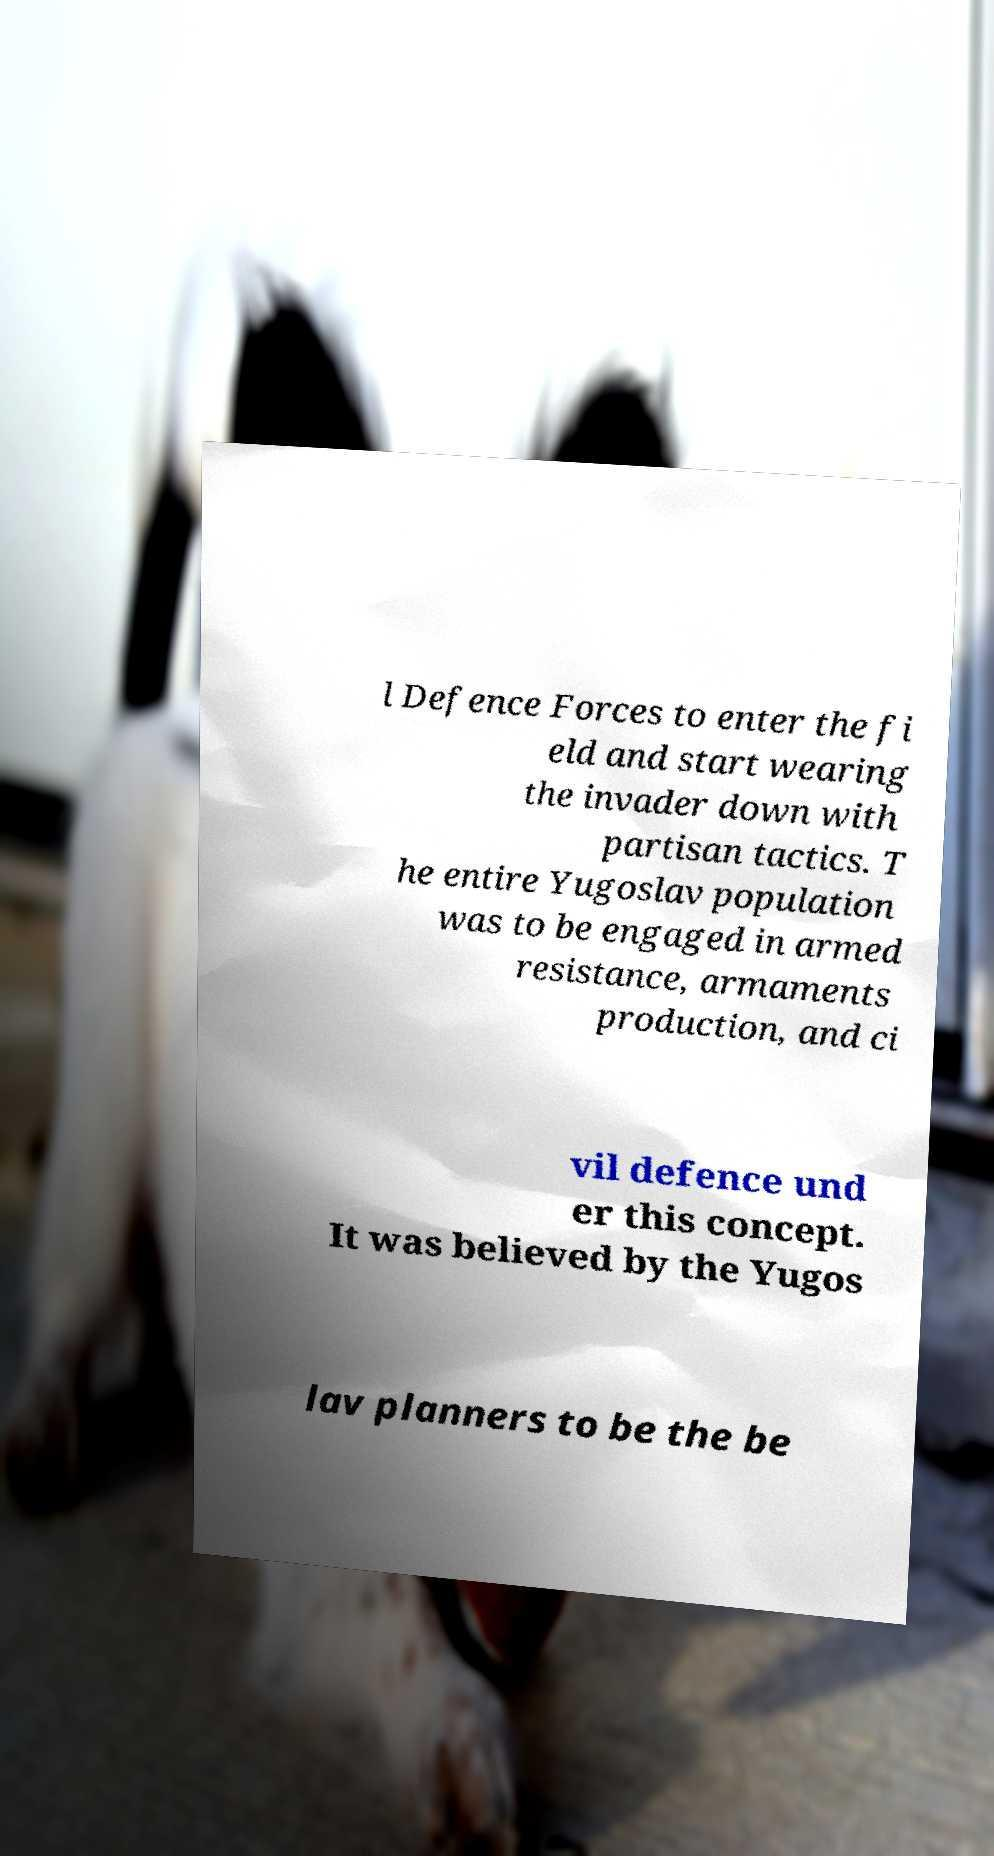I need the written content from this picture converted into text. Can you do that? l Defence Forces to enter the fi eld and start wearing the invader down with partisan tactics. T he entire Yugoslav population was to be engaged in armed resistance, armaments production, and ci vil defence und er this concept. It was believed by the Yugos lav planners to be the be 